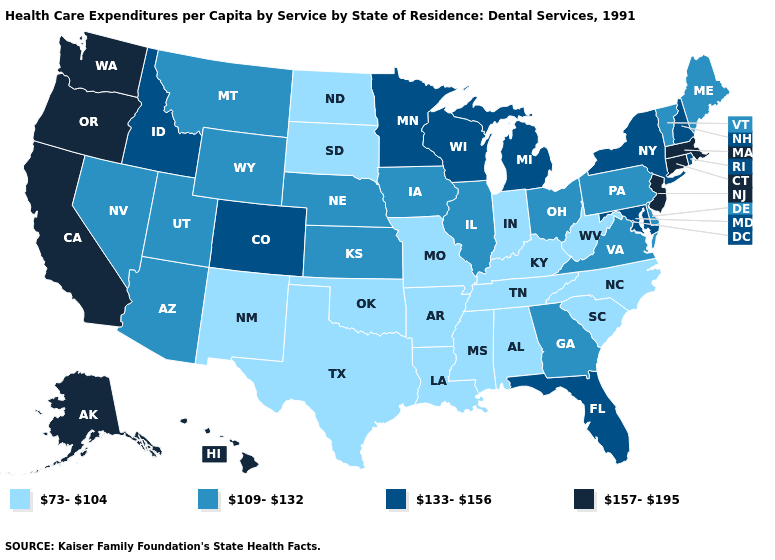Among the states that border North Dakota , does Montana have the lowest value?
Answer briefly. No. What is the value of Louisiana?
Answer briefly. 73-104. Does Connecticut have the highest value in the USA?
Keep it brief. Yes. Name the states that have a value in the range 109-132?
Write a very short answer. Arizona, Delaware, Georgia, Illinois, Iowa, Kansas, Maine, Montana, Nebraska, Nevada, Ohio, Pennsylvania, Utah, Vermont, Virginia, Wyoming. Among the states that border Kentucky , which have the highest value?
Keep it brief. Illinois, Ohio, Virginia. Does Alaska have the highest value in the USA?
Answer briefly. Yes. Among the states that border Pennsylvania , which have the highest value?
Short answer required. New Jersey. What is the value of New Hampshire?
Keep it brief. 133-156. What is the lowest value in the USA?
Answer briefly. 73-104. Does California have the highest value in the USA?
Short answer required. Yes. What is the highest value in the USA?
Concise answer only. 157-195. Does the map have missing data?
Keep it brief. No. What is the value of Nebraska?
Be succinct. 109-132. What is the highest value in the South ?
Answer briefly. 133-156. What is the value of Texas?
Quick response, please. 73-104. 